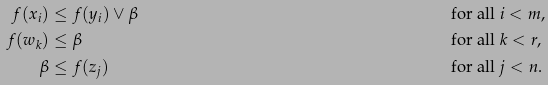<formula> <loc_0><loc_0><loc_500><loc_500>f ( x _ { i } ) & \leq f ( y _ { i } ) \vee \beta & & \quad \text { for all } i < m , \\ f ( w _ { k } ) & \leq \beta & & \quad \text { for all } k < r , \\ \beta & \leq f ( z _ { j } ) & & \quad \text { for all } j < n .</formula> 